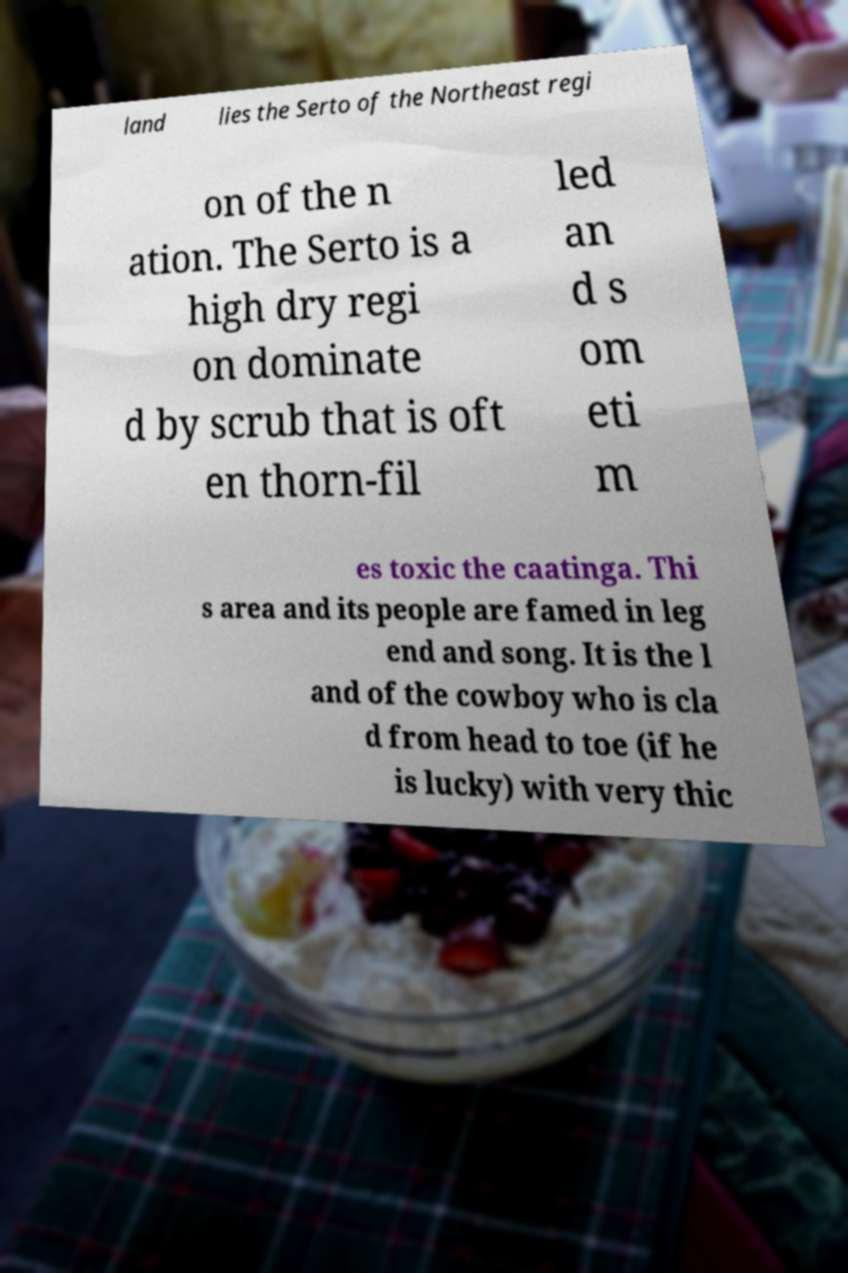Could you assist in decoding the text presented in this image and type it out clearly? land lies the Serto of the Northeast regi on of the n ation. The Serto is a high dry regi on dominate d by scrub that is oft en thorn-fil led an d s om eti m es toxic the caatinga. Thi s area and its people are famed in leg end and song. It is the l and of the cowboy who is cla d from head to toe (if he is lucky) with very thic 